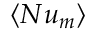Convert formula to latex. <formula><loc_0><loc_0><loc_500><loc_500>\langle N u _ { m } \rangle</formula> 